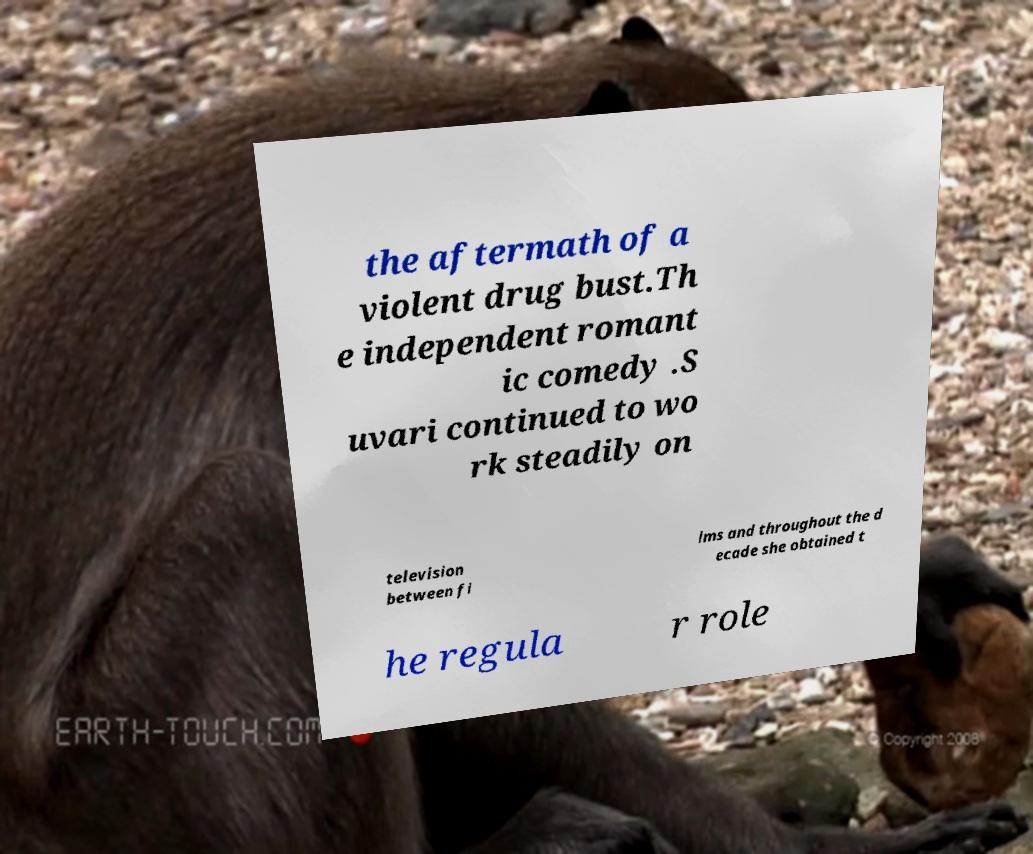Could you extract and type out the text from this image? the aftermath of a violent drug bust.Th e independent romant ic comedy .S uvari continued to wo rk steadily on television between fi lms and throughout the d ecade she obtained t he regula r role 